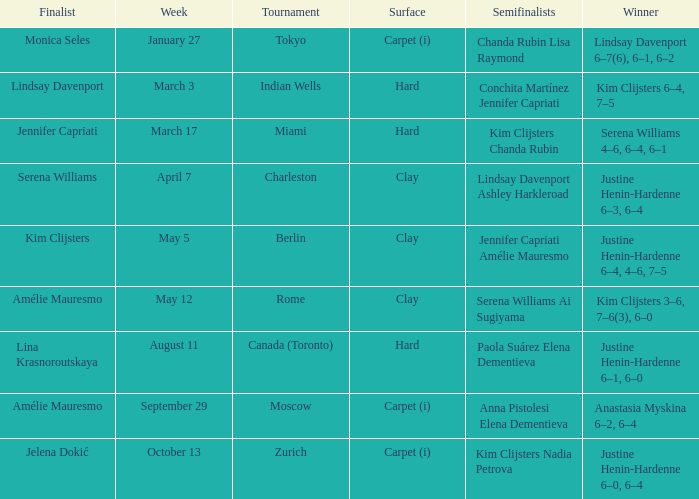Who was the finalist in Miami? Jennifer Capriati. 